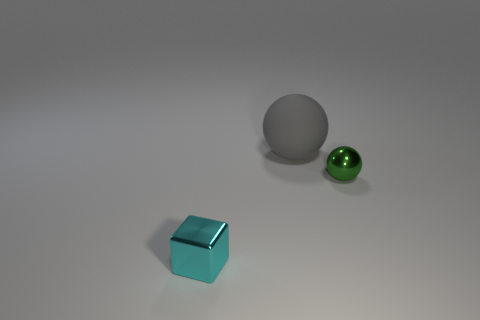Add 1 spheres. How many objects exist? 4 Subtract all balls. How many objects are left? 1 Add 2 large purple cylinders. How many large purple cylinders exist? 2 Subtract 0 cyan cylinders. How many objects are left? 3 Subtract all yellow spheres. Subtract all tiny cyan objects. How many objects are left? 2 Add 1 large spheres. How many large spheres are left? 2 